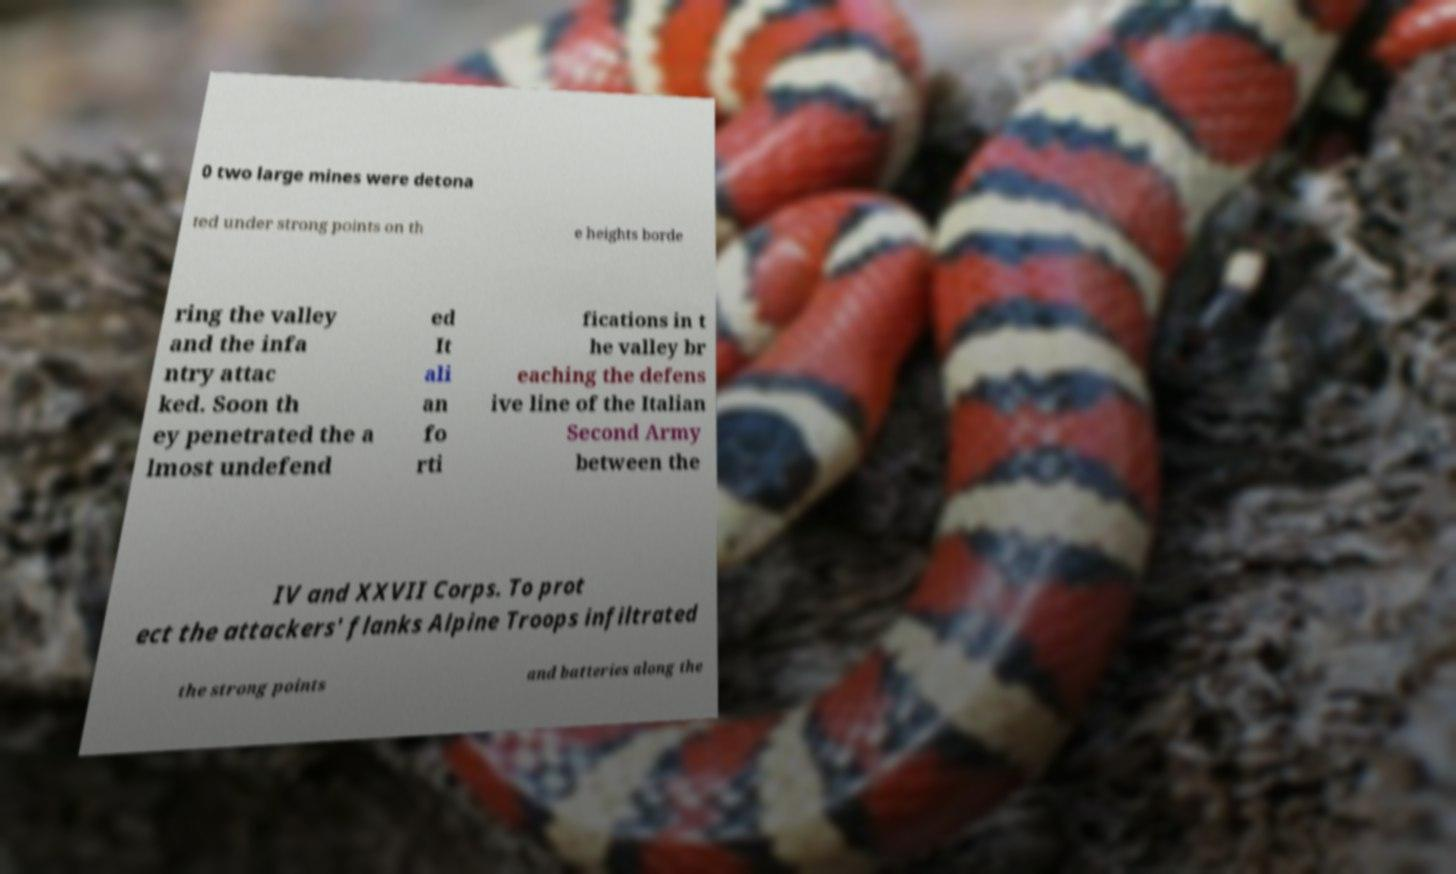Could you extract and type out the text from this image? 0 two large mines were detona ted under strong points on th e heights borde ring the valley and the infa ntry attac ked. Soon th ey penetrated the a lmost undefend ed It ali an fo rti fications in t he valley br eaching the defens ive line of the Italian Second Army between the IV and XXVII Corps. To prot ect the attackers' flanks Alpine Troops infiltrated the strong points and batteries along the 